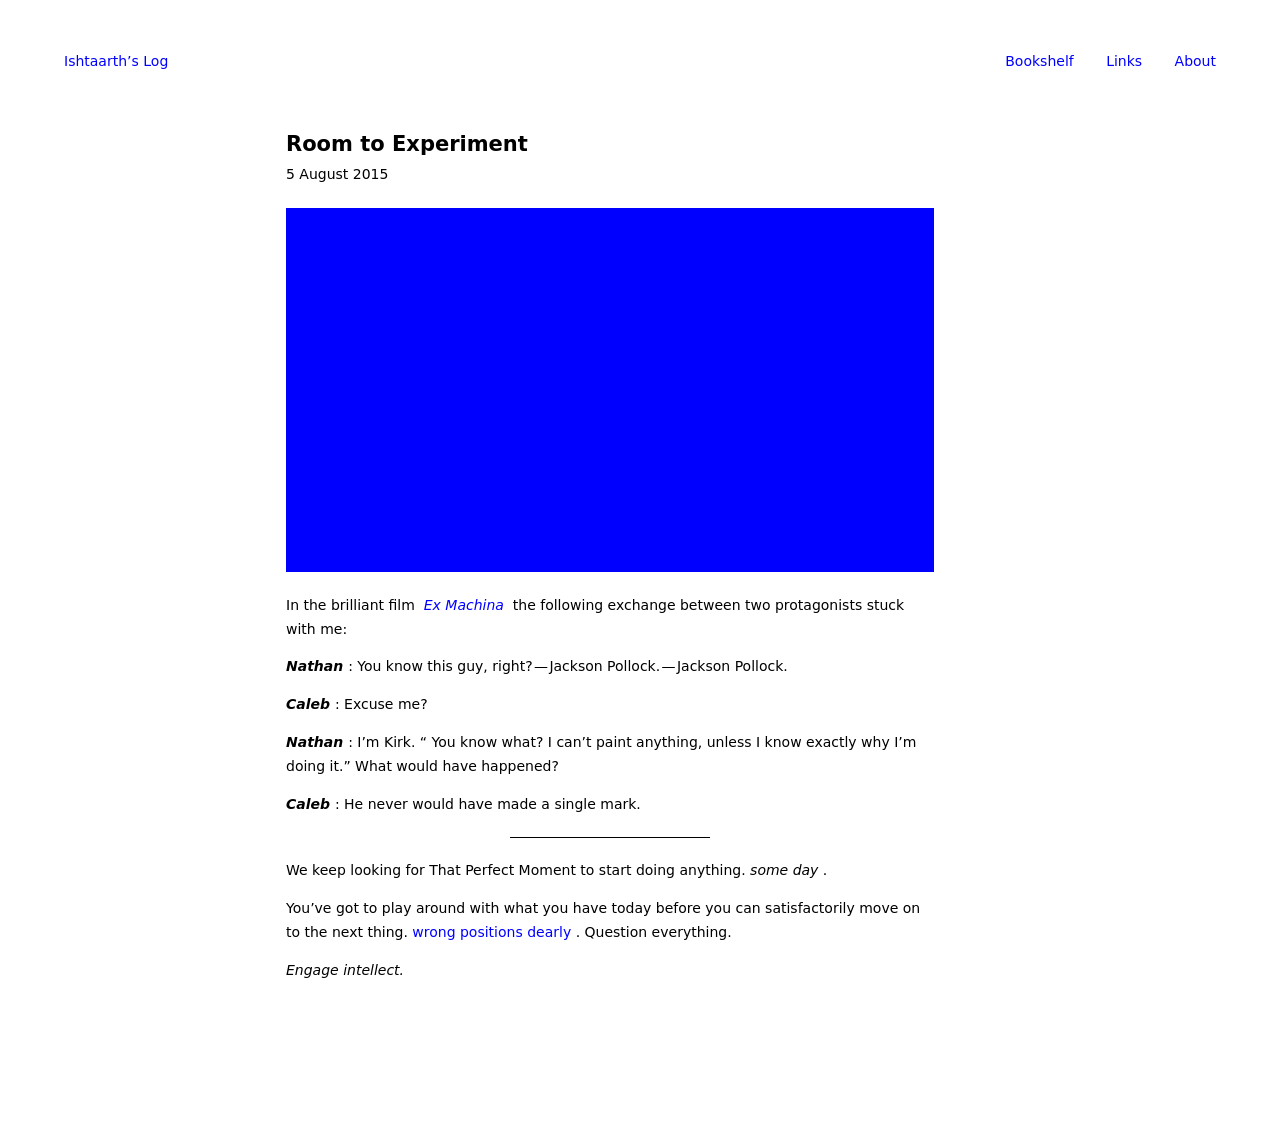How can I start building this website with HTML from the ground up? To start building a website with HTML, begin by learning the basics of HTML tags and their functions. You should understand the structure, which includes tags like <html>, <head>, <title>, and <body>. Start with a simple 'Hello World' example and gradually add elements such as headings, paragraphs, links, and images. Use external CSS for styling to keep your HTML clean. As you become more comfortable with HTML and CSS, consider learning JavaScript to add interactivity to your website. 